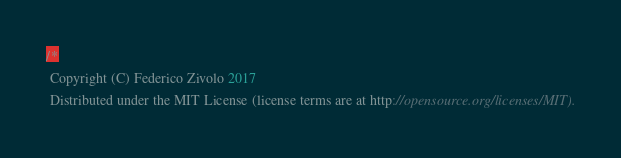Convert code to text. <code><loc_0><loc_0><loc_500><loc_500><_JavaScript_>/*
 Copyright (C) Federico Zivolo 2017
 Distributed under the MIT License (license terms are at http://opensource.org/licenses/MIT).</code> 